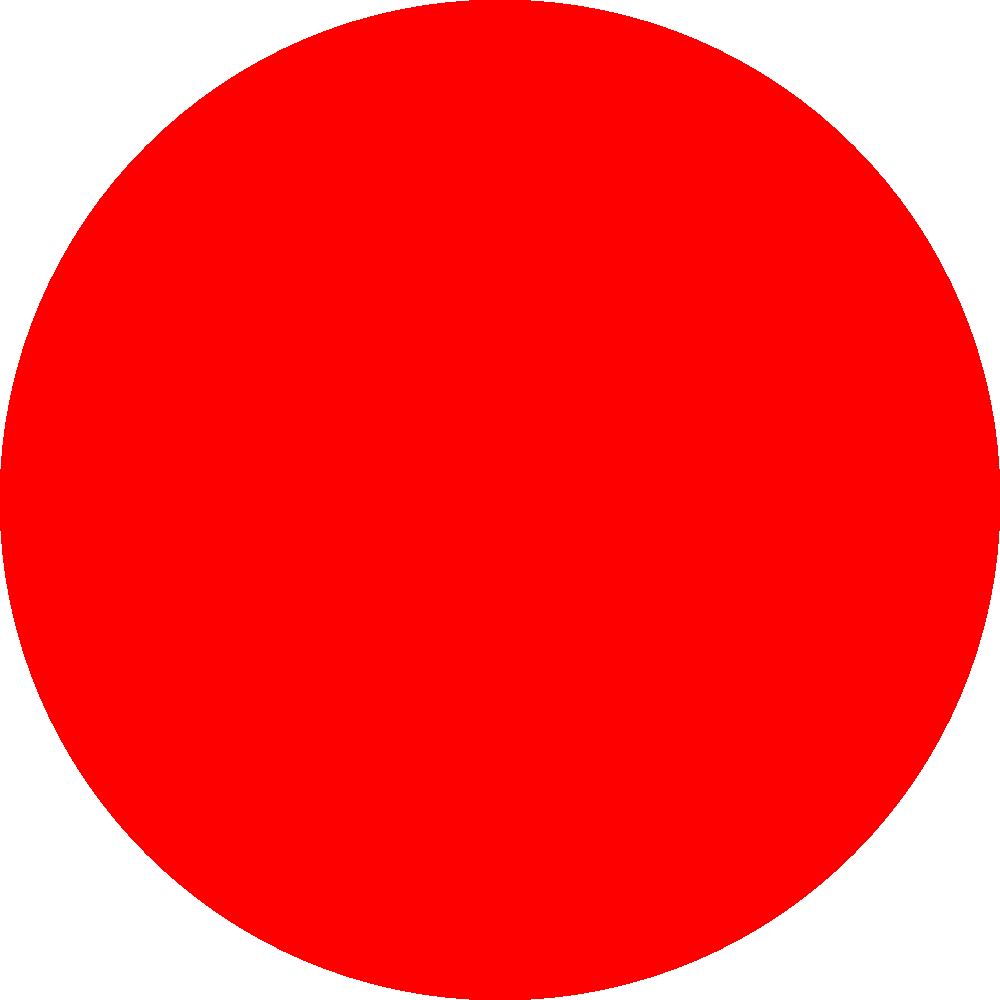In game design, complementary colors are often used to create visual contrast and draw attention to important elements. Based on the color wheel shown, which color would be most effective to use for highlighting important items or user interface elements in a game with a predominantly blue color scheme? To determine the most effective color for highlighting in a predominantly blue game:

1. Locate blue on the color wheel (bottom left sector).
2. Identify its complementary color by finding the color directly opposite on the wheel.
3. The color opposite blue is orange (between red and yellow).
4. Complementary colors create maximum contrast when used together.
5. In game design, high contrast helps important elements stand out.
6. Using orange highlights in a blue-dominated game would create strong visual pop.
7. This contrast would naturally draw the player's attention to important items or UI elements.
8. The use of complementary colors also maintains color harmony in the overall design.

Therefore, orange would be the most effective color for highlighting important elements in a predominantly blue game environment.
Answer: Orange 